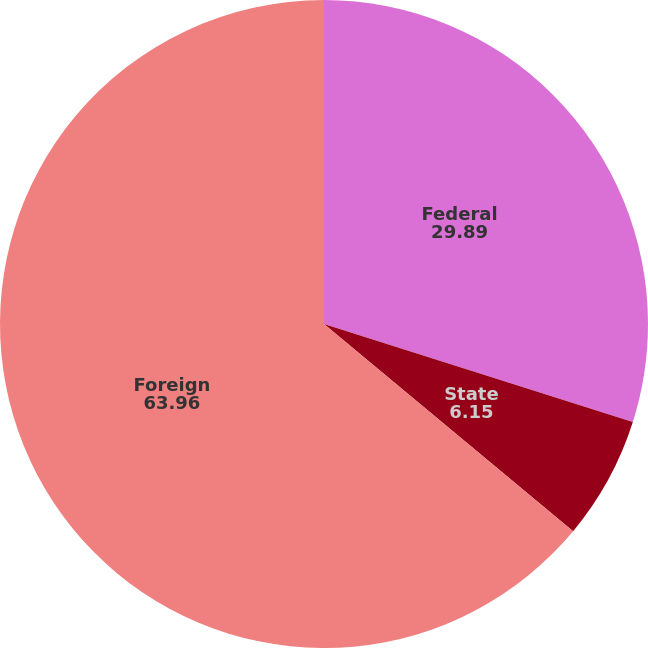Convert chart to OTSL. <chart><loc_0><loc_0><loc_500><loc_500><pie_chart><fcel>Federal<fcel>State<fcel>Foreign<nl><fcel>29.89%<fcel>6.15%<fcel>63.96%<nl></chart> 